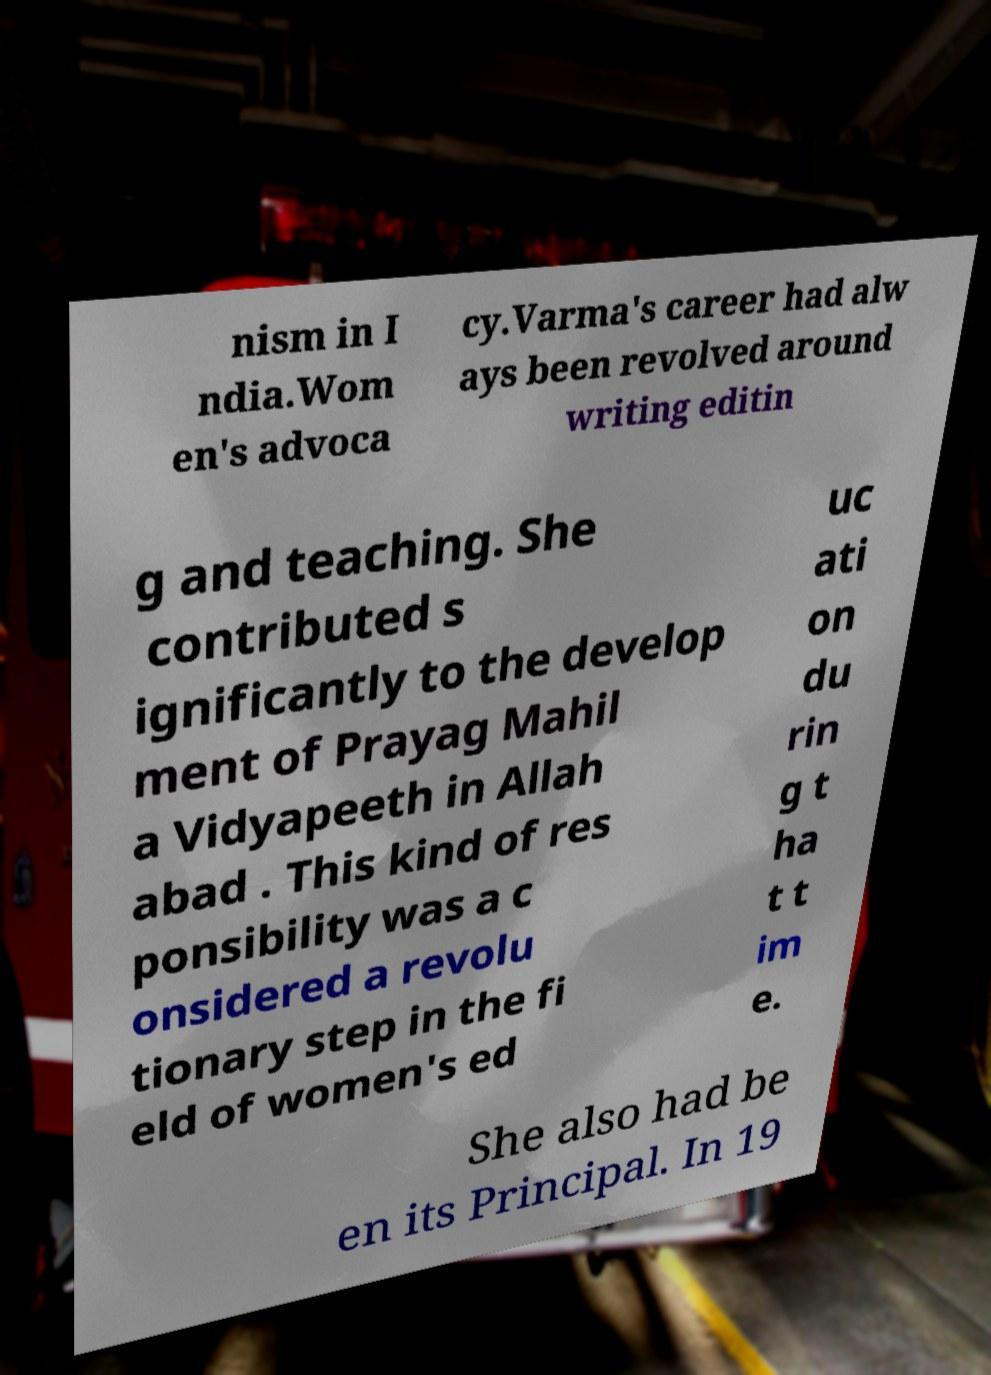I need the written content from this picture converted into text. Can you do that? nism in I ndia.Wom en's advoca cy.Varma's career had alw ays been revolved around writing editin g and teaching. She contributed s ignificantly to the develop ment of Prayag Mahil a Vidyapeeth in Allah abad . This kind of res ponsibility was a c onsidered a revolu tionary step in the fi eld of women's ed uc ati on du rin g t ha t t im e. She also had be en its Principal. In 19 